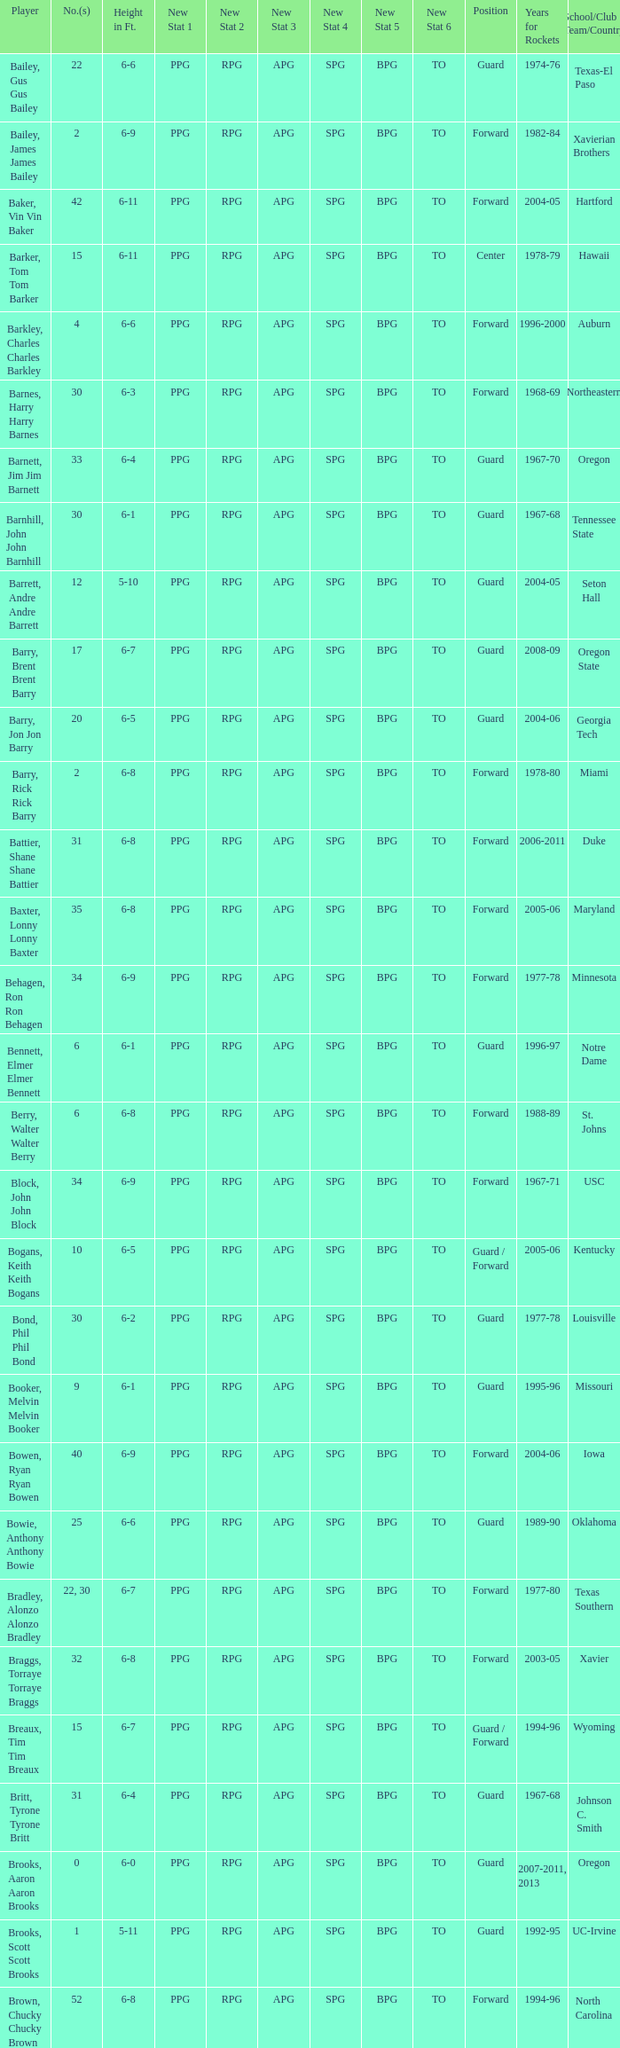What position is number 35 whose height is 6-6? Forward. 